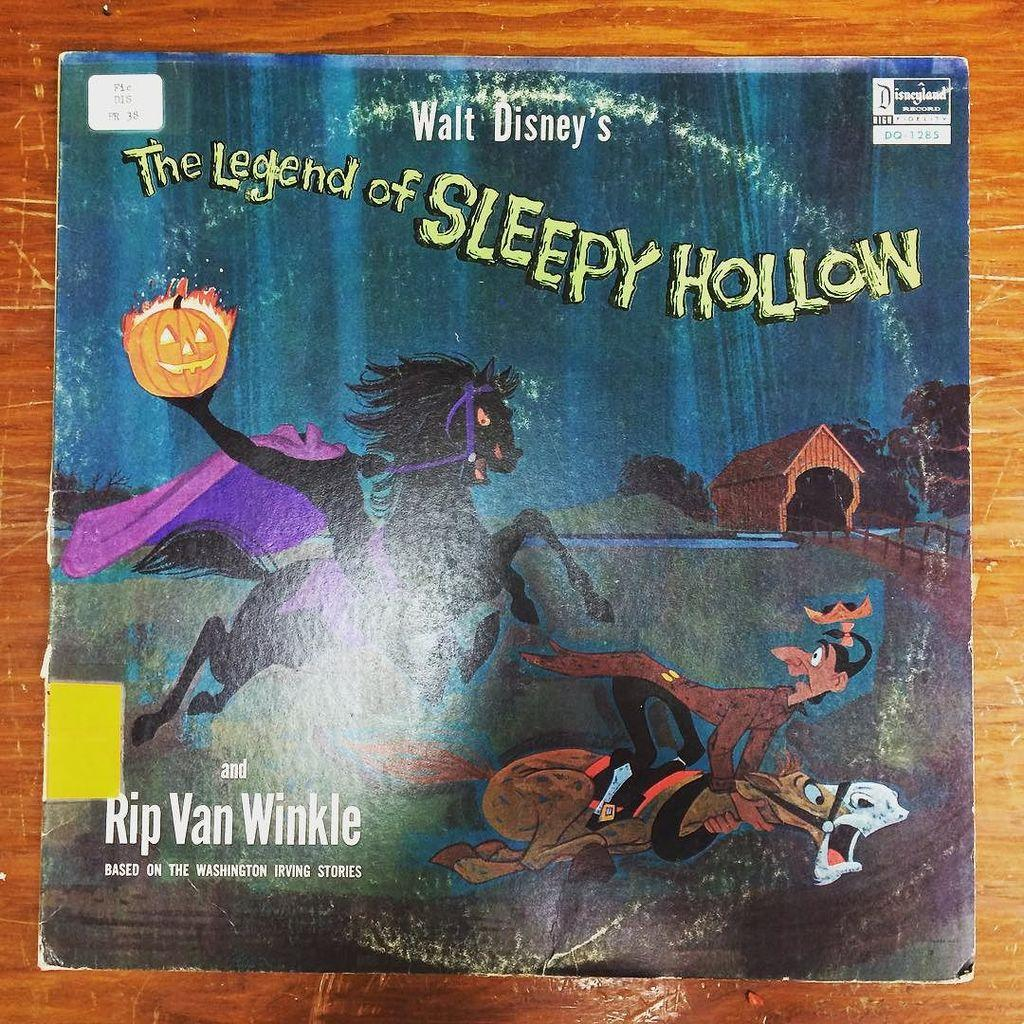<image>
Describe the image concisely. Cover for The Legend of Sleepy Hollow showing a person running from a monster. 